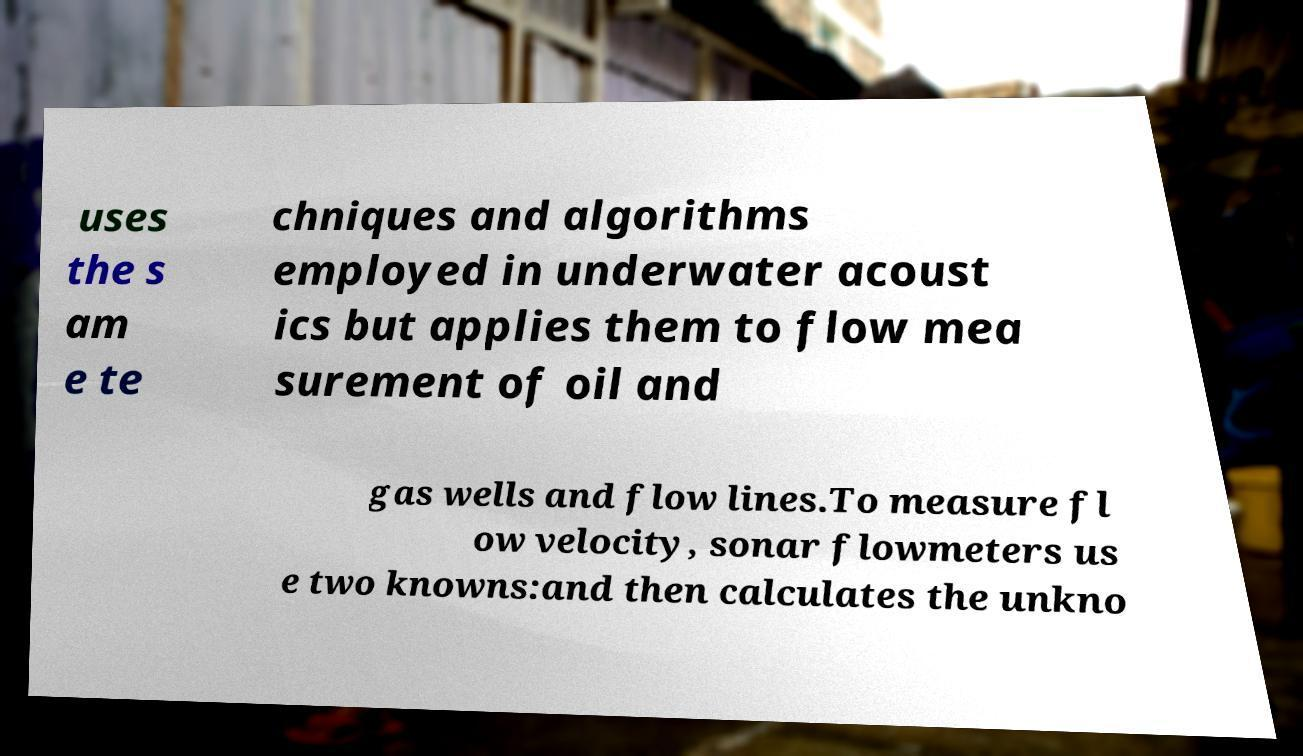Please read and relay the text visible in this image. What does it say? uses the s am e te chniques and algorithms employed in underwater acoust ics but applies them to flow mea surement of oil and gas wells and flow lines.To measure fl ow velocity, sonar flowmeters us e two knowns:and then calculates the unkno 